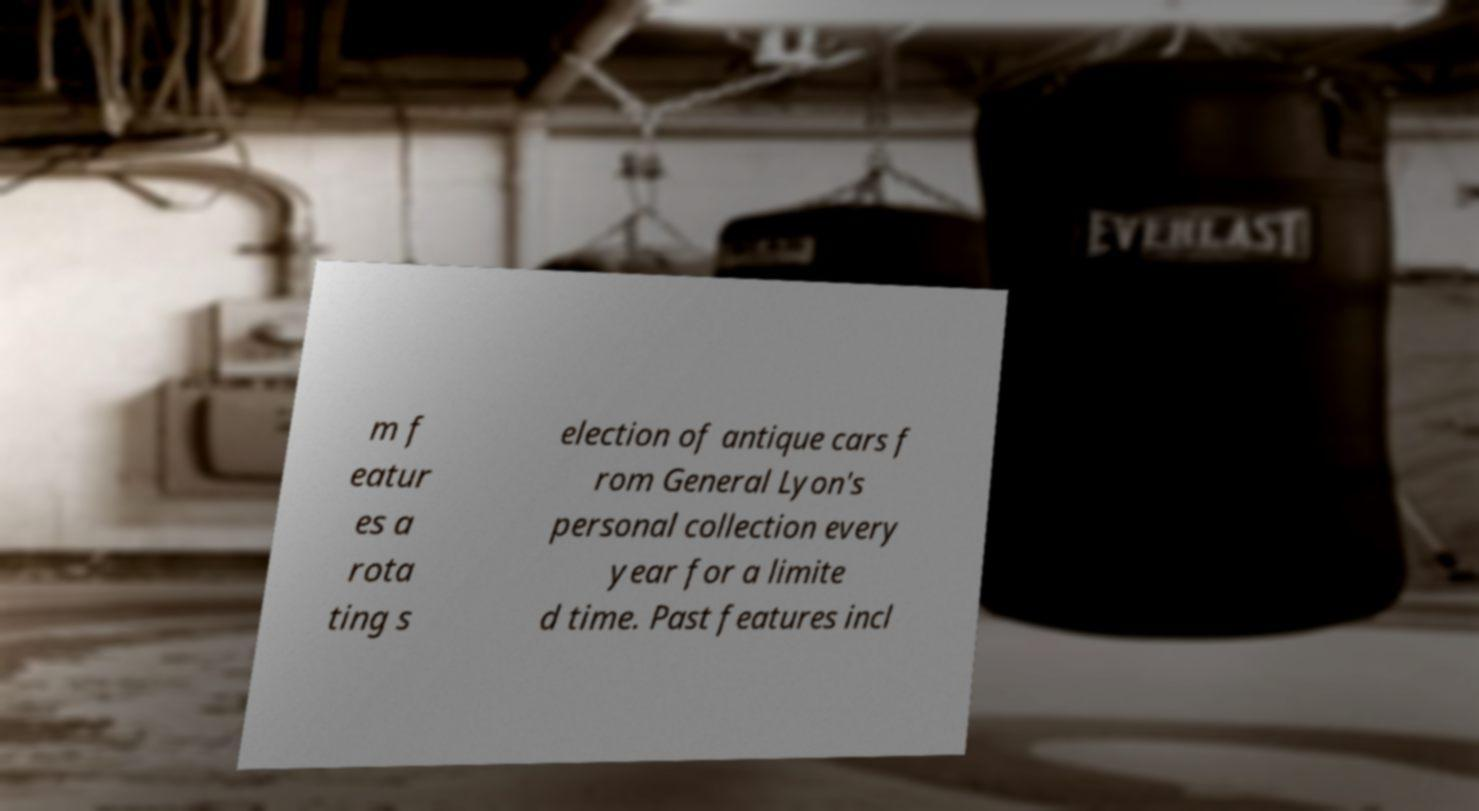I need the written content from this picture converted into text. Can you do that? m f eatur es a rota ting s election of antique cars f rom General Lyon's personal collection every year for a limite d time. Past features incl 